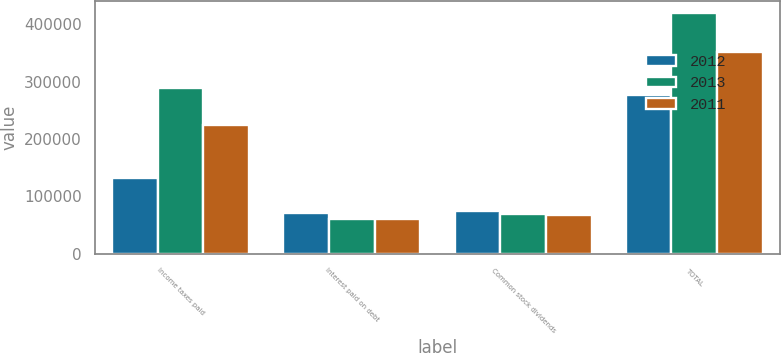Convert chart. <chart><loc_0><loc_0><loc_500><loc_500><stacked_bar_chart><ecel><fcel>Income taxes paid<fcel>Interest paid on debt<fcel>Common stock dividends<fcel>TOTAL<nl><fcel>2012<fcel>132487<fcel>70741<fcel>74128<fcel>277356<nl><fcel>2013<fcel>289850<fcel>60188<fcel>69393<fcel>419431<nl><fcel>2011<fcel>223950<fcel>60244<fcel>67385<fcel>351579<nl></chart> 